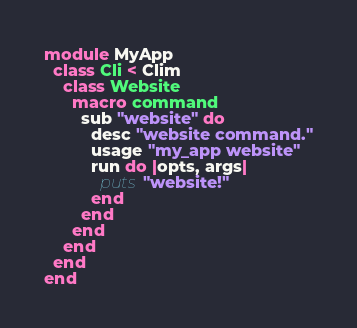Convert code to text. <code><loc_0><loc_0><loc_500><loc_500><_Crystal_>module MyApp
  class Cli < Clim
    class Website
      macro command
        sub "website" do
          desc "website command."
          usage "my_app website"
          run do |opts, args|
            puts "website!"
          end
        end
      end
    end
  end
end
</code> 